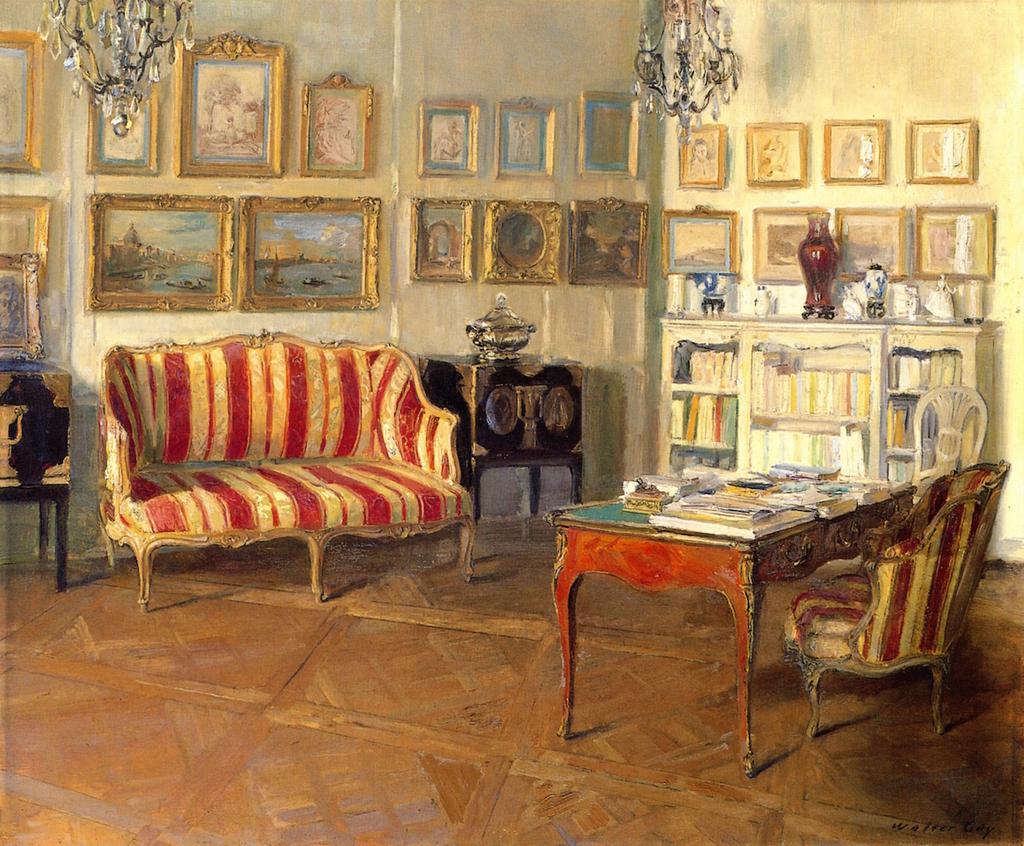In one or two sentences, can you explain what this image depicts? I see this is a painting and there is a sofa, 2 chairs, a table on which there are few books on it and a rack over here and lot of books in it and on the rack there are few things and on the wall there are photo frames. 